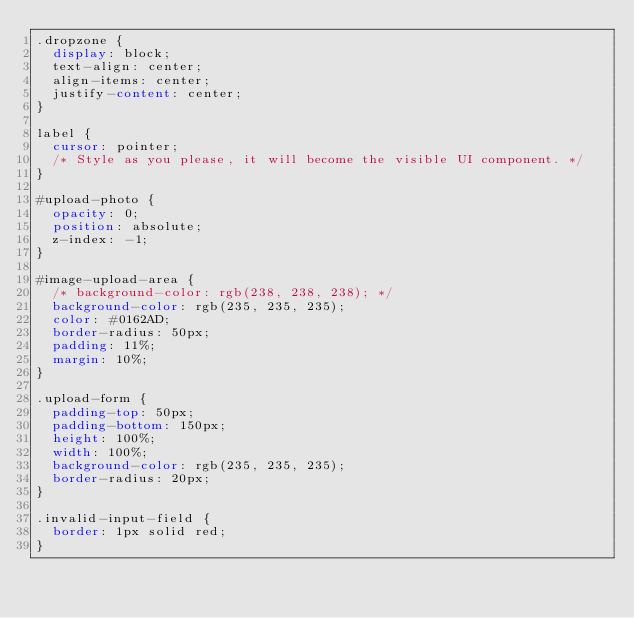<code> <loc_0><loc_0><loc_500><loc_500><_CSS_>.dropzone {
  display: block;
  text-align: center;
  align-items: center;
  justify-content: center;
}

label {
  cursor: pointer;
  /* Style as you please, it will become the visible UI component. */
}

#upload-photo {
  opacity: 0;
  position: absolute;
  z-index: -1;
}

#image-upload-area {
  /* background-color: rgb(238, 238, 238); */
  background-color: rgb(235, 235, 235);
  color: #0162AD;
  border-radius: 50px;
  padding: 11%;
  margin: 10%;
}

.upload-form {
  padding-top: 50px;
  padding-bottom: 150px;
  height: 100%;
  width: 100%;
  background-color: rgb(235, 235, 235);
  border-radius: 20px;
}

.invalid-input-field {
  border: 1px solid red;
}</code> 